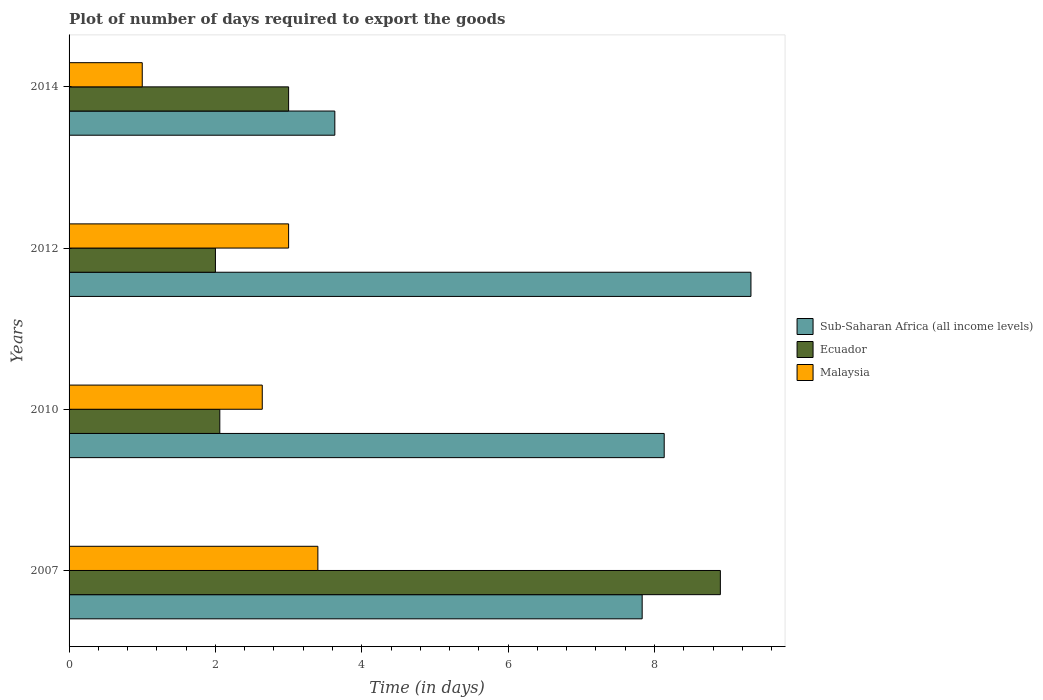How many different coloured bars are there?
Provide a succinct answer. 3. Are the number of bars on each tick of the Y-axis equal?
Offer a terse response. Yes. What is the time required to export goods in Sub-Saharan Africa (all income levels) in 2012?
Provide a short and direct response. 9.32. Across all years, what is the maximum time required to export goods in Ecuador?
Ensure brevity in your answer.  8.9. In which year was the time required to export goods in Malaysia maximum?
Keep it short and to the point. 2007. In which year was the time required to export goods in Malaysia minimum?
Your answer should be compact. 2014. What is the total time required to export goods in Sub-Saharan Africa (all income levels) in the graph?
Your response must be concise. 28.91. What is the difference between the time required to export goods in Malaysia in 2010 and that in 2012?
Offer a terse response. -0.36. What is the difference between the time required to export goods in Sub-Saharan Africa (all income levels) in 2014 and the time required to export goods in Ecuador in 2007?
Offer a terse response. -5.27. What is the average time required to export goods in Ecuador per year?
Make the answer very short. 3.99. In the year 2014, what is the difference between the time required to export goods in Sub-Saharan Africa (all income levels) and time required to export goods in Ecuador?
Provide a short and direct response. 0.63. In how many years, is the time required to export goods in Ecuador greater than 4 days?
Your answer should be compact. 1. What is the ratio of the time required to export goods in Sub-Saharan Africa (all income levels) in 2012 to that in 2014?
Keep it short and to the point. 2.57. Is the time required to export goods in Sub-Saharan Africa (all income levels) in 2007 less than that in 2010?
Your answer should be compact. Yes. Is the difference between the time required to export goods in Sub-Saharan Africa (all income levels) in 2010 and 2014 greater than the difference between the time required to export goods in Ecuador in 2010 and 2014?
Provide a short and direct response. Yes. What is the difference between the highest and the second highest time required to export goods in Malaysia?
Your response must be concise. 0.4. Is the sum of the time required to export goods in Malaysia in 2007 and 2010 greater than the maximum time required to export goods in Sub-Saharan Africa (all income levels) across all years?
Your response must be concise. No. What does the 1st bar from the top in 2014 represents?
Offer a terse response. Malaysia. What does the 1st bar from the bottom in 2007 represents?
Make the answer very short. Sub-Saharan Africa (all income levels). Is it the case that in every year, the sum of the time required to export goods in Sub-Saharan Africa (all income levels) and time required to export goods in Ecuador is greater than the time required to export goods in Malaysia?
Offer a terse response. Yes. Are all the bars in the graph horizontal?
Ensure brevity in your answer.  Yes. Are the values on the major ticks of X-axis written in scientific E-notation?
Your answer should be very brief. No. Does the graph contain grids?
Your answer should be compact. No. Where does the legend appear in the graph?
Make the answer very short. Center right. How many legend labels are there?
Make the answer very short. 3. What is the title of the graph?
Keep it short and to the point. Plot of number of days required to export the goods. Does "Somalia" appear as one of the legend labels in the graph?
Offer a very short reply. No. What is the label or title of the X-axis?
Your answer should be very brief. Time (in days). What is the Time (in days) of Sub-Saharan Africa (all income levels) in 2007?
Give a very brief answer. 7.83. What is the Time (in days) in Ecuador in 2007?
Offer a very short reply. 8.9. What is the Time (in days) in Sub-Saharan Africa (all income levels) in 2010?
Provide a succinct answer. 8.13. What is the Time (in days) of Ecuador in 2010?
Make the answer very short. 2.06. What is the Time (in days) in Malaysia in 2010?
Offer a very short reply. 2.64. What is the Time (in days) of Sub-Saharan Africa (all income levels) in 2012?
Your answer should be compact. 9.32. What is the Time (in days) of Ecuador in 2012?
Ensure brevity in your answer.  2. What is the Time (in days) of Sub-Saharan Africa (all income levels) in 2014?
Provide a succinct answer. 3.63. Across all years, what is the maximum Time (in days) of Sub-Saharan Africa (all income levels)?
Offer a terse response. 9.32. Across all years, what is the minimum Time (in days) in Sub-Saharan Africa (all income levels)?
Your response must be concise. 3.63. Across all years, what is the minimum Time (in days) of Ecuador?
Provide a short and direct response. 2. What is the total Time (in days) of Sub-Saharan Africa (all income levels) in the graph?
Your response must be concise. 28.91. What is the total Time (in days) in Ecuador in the graph?
Offer a very short reply. 15.96. What is the total Time (in days) in Malaysia in the graph?
Your answer should be very brief. 10.04. What is the difference between the Time (in days) in Sub-Saharan Africa (all income levels) in 2007 and that in 2010?
Ensure brevity in your answer.  -0.3. What is the difference between the Time (in days) in Ecuador in 2007 and that in 2010?
Your response must be concise. 6.84. What is the difference between the Time (in days) of Malaysia in 2007 and that in 2010?
Your answer should be very brief. 0.76. What is the difference between the Time (in days) in Sub-Saharan Africa (all income levels) in 2007 and that in 2012?
Keep it short and to the point. -1.49. What is the difference between the Time (in days) in Sub-Saharan Africa (all income levels) in 2007 and that in 2014?
Give a very brief answer. 4.2. What is the difference between the Time (in days) of Malaysia in 2007 and that in 2014?
Offer a terse response. 2.4. What is the difference between the Time (in days) in Sub-Saharan Africa (all income levels) in 2010 and that in 2012?
Offer a very short reply. -1.19. What is the difference between the Time (in days) of Ecuador in 2010 and that in 2012?
Your answer should be compact. 0.06. What is the difference between the Time (in days) in Malaysia in 2010 and that in 2012?
Your answer should be very brief. -0.36. What is the difference between the Time (in days) in Sub-Saharan Africa (all income levels) in 2010 and that in 2014?
Make the answer very short. 4.5. What is the difference between the Time (in days) of Ecuador in 2010 and that in 2014?
Make the answer very short. -0.94. What is the difference between the Time (in days) in Malaysia in 2010 and that in 2014?
Give a very brief answer. 1.64. What is the difference between the Time (in days) in Sub-Saharan Africa (all income levels) in 2012 and that in 2014?
Your response must be concise. 5.69. What is the difference between the Time (in days) in Ecuador in 2012 and that in 2014?
Offer a very short reply. -1. What is the difference between the Time (in days) of Malaysia in 2012 and that in 2014?
Ensure brevity in your answer.  2. What is the difference between the Time (in days) in Sub-Saharan Africa (all income levels) in 2007 and the Time (in days) in Ecuador in 2010?
Offer a terse response. 5.77. What is the difference between the Time (in days) in Sub-Saharan Africa (all income levels) in 2007 and the Time (in days) in Malaysia in 2010?
Offer a terse response. 5.19. What is the difference between the Time (in days) in Ecuador in 2007 and the Time (in days) in Malaysia in 2010?
Offer a terse response. 6.26. What is the difference between the Time (in days) of Sub-Saharan Africa (all income levels) in 2007 and the Time (in days) of Ecuador in 2012?
Give a very brief answer. 5.83. What is the difference between the Time (in days) of Sub-Saharan Africa (all income levels) in 2007 and the Time (in days) of Malaysia in 2012?
Your answer should be compact. 4.83. What is the difference between the Time (in days) of Sub-Saharan Africa (all income levels) in 2007 and the Time (in days) of Ecuador in 2014?
Ensure brevity in your answer.  4.83. What is the difference between the Time (in days) of Sub-Saharan Africa (all income levels) in 2007 and the Time (in days) of Malaysia in 2014?
Your response must be concise. 6.83. What is the difference between the Time (in days) in Ecuador in 2007 and the Time (in days) in Malaysia in 2014?
Offer a terse response. 7.9. What is the difference between the Time (in days) in Sub-Saharan Africa (all income levels) in 2010 and the Time (in days) in Ecuador in 2012?
Make the answer very short. 6.13. What is the difference between the Time (in days) in Sub-Saharan Africa (all income levels) in 2010 and the Time (in days) in Malaysia in 2012?
Your response must be concise. 5.13. What is the difference between the Time (in days) of Ecuador in 2010 and the Time (in days) of Malaysia in 2012?
Provide a succinct answer. -0.94. What is the difference between the Time (in days) in Sub-Saharan Africa (all income levels) in 2010 and the Time (in days) in Ecuador in 2014?
Provide a short and direct response. 5.13. What is the difference between the Time (in days) in Sub-Saharan Africa (all income levels) in 2010 and the Time (in days) in Malaysia in 2014?
Your answer should be compact. 7.13. What is the difference between the Time (in days) in Ecuador in 2010 and the Time (in days) in Malaysia in 2014?
Provide a short and direct response. 1.06. What is the difference between the Time (in days) of Sub-Saharan Africa (all income levels) in 2012 and the Time (in days) of Ecuador in 2014?
Provide a succinct answer. 6.32. What is the difference between the Time (in days) of Sub-Saharan Africa (all income levels) in 2012 and the Time (in days) of Malaysia in 2014?
Make the answer very short. 8.32. What is the average Time (in days) of Sub-Saharan Africa (all income levels) per year?
Provide a short and direct response. 7.23. What is the average Time (in days) in Ecuador per year?
Give a very brief answer. 3.99. What is the average Time (in days) of Malaysia per year?
Offer a terse response. 2.51. In the year 2007, what is the difference between the Time (in days) in Sub-Saharan Africa (all income levels) and Time (in days) in Ecuador?
Provide a succinct answer. -1.07. In the year 2007, what is the difference between the Time (in days) of Sub-Saharan Africa (all income levels) and Time (in days) of Malaysia?
Offer a terse response. 4.43. In the year 2007, what is the difference between the Time (in days) in Ecuador and Time (in days) in Malaysia?
Ensure brevity in your answer.  5.5. In the year 2010, what is the difference between the Time (in days) of Sub-Saharan Africa (all income levels) and Time (in days) of Ecuador?
Provide a short and direct response. 6.07. In the year 2010, what is the difference between the Time (in days) of Sub-Saharan Africa (all income levels) and Time (in days) of Malaysia?
Your answer should be compact. 5.49. In the year 2010, what is the difference between the Time (in days) of Ecuador and Time (in days) of Malaysia?
Provide a succinct answer. -0.58. In the year 2012, what is the difference between the Time (in days) of Sub-Saharan Africa (all income levels) and Time (in days) of Ecuador?
Provide a succinct answer. 7.32. In the year 2012, what is the difference between the Time (in days) of Sub-Saharan Africa (all income levels) and Time (in days) of Malaysia?
Make the answer very short. 6.32. In the year 2014, what is the difference between the Time (in days) of Sub-Saharan Africa (all income levels) and Time (in days) of Ecuador?
Your answer should be very brief. 0.63. In the year 2014, what is the difference between the Time (in days) in Sub-Saharan Africa (all income levels) and Time (in days) in Malaysia?
Your answer should be very brief. 2.63. What is the ratio of the Time (in days) in Ecuador in 2007 to that in 2010?
Give a very brief answer. 4.32. What is the ratio of the Time (in days) of Malaysia in 2007 to that in 2010?
Your answer should be compact. 1.29. What is the ratio of the Time (in days) in Sub-Saharan Africa (all income levels) in 2007 to that in 2012?
Make the answer very short. 0.84. What is the ratio of the Time (in days) of Ecuador in 2007 to that in 2012?
Make the answer very short. 4.45. What is the ratio of the Time (in days) of Malaysia in 2007 to that in 2012?
Keep it short and to the point. 1.13. What is the ratio of the Time (in days) of Sub-Saharan Africa (all income levels) in 2007 to that in 2014?
Make the answer very short. 2.16. What is the ratio of the Time (in days) of Ecuador in 2007 to that in 2014?
Your answer should be compact. 2.97. What is the ratio of the Time (in days) of Sub-Saharan Africa (all income levels) in 2010 to that in 2012?
Provide a succinct answer. 0.87. What is the ratio of the Time (in days) in Ecuador in 2010 to that in 2012?
Keep it short and to the point. 1.03. What is the ratio of the Time (in days) of Malaysia in 2010 to that in 2012?
Give a very brief answer. 0.88. What is the ratio of the Time (in days) of Sub-Saharan Africa (all income levels) in 2010 to that in 2014?
Provide a short and direct response. 2.24. What is the ratio of the Time (in days) in Ecuador in 2010 to that in 2014?
Provide a short and direct response. 0.69. What is the ratio of the Time (in days) of Malaysia in 2010 to that in 2014?
Your response must be concise. 2.64. What is the ratio of the Time (in days) of Sub-Saharan Africa (all income levels) in 2012 to that in 2014?
Your answer should be compact. 2.57. What is the ratio of the Time (in days) in Ecuador in 2012 to that in 2014?
Your answer should be compact. 0.67. What is the ratio of the Time (in days) in Malaysia in 2012 to that in 2014?
Provide a succinct answer. 3. What is the difference between the highest and the second highest Time (in days) in Sub-Saharan Africa (all income levels)?
Give a very brief answer. 1.19. What is the difference between the highest and the lowest Time (in days) of Sub-Saharan Africa (all income levels)?
Your answer should be very brief. 5.69. 